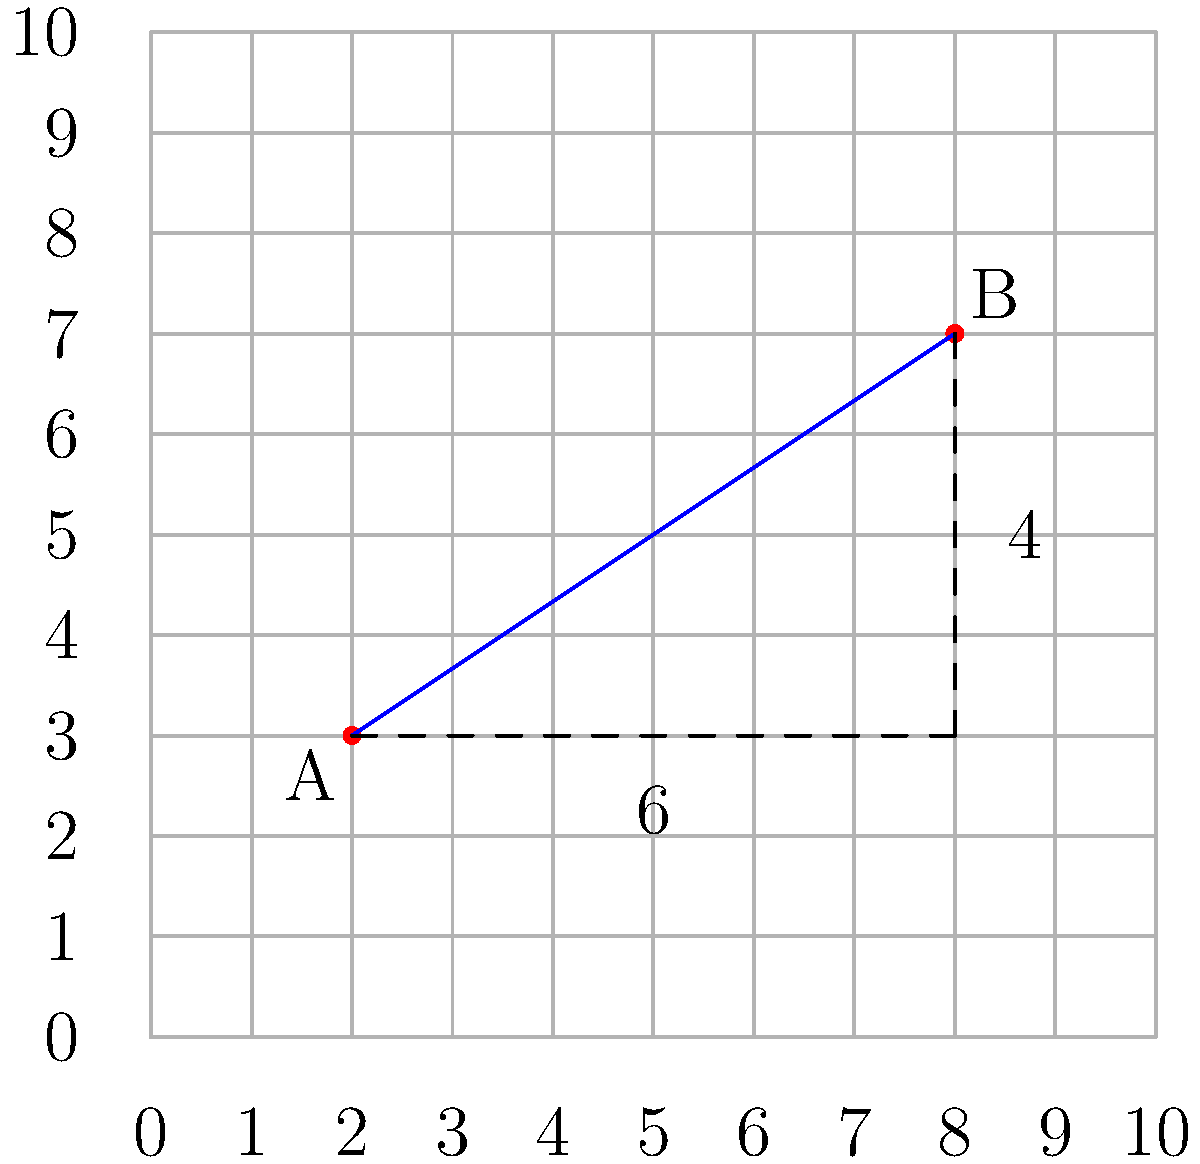As you chart a new territory, you plot two significant landmarks on your map: point A (2, 3) and point B (8, 7). Using the Pythagorean theorem, calculate the direct distance between these two points. Round your answer to two decimal places. To calculate the distance between two points using the Pythagorean theorem, we follow these steps:

1. Identify the coordinates:
   Point A: (2, 3)
   Point B: (8, 7)

2. Calculate the difference in x-coordinates:
   $\Delta x = 8 - 2 = 6$

3. Calculate the difference in y-coordinates:
   $\Delta y = 7 - 3 = 4$

4. Apply the Pythagorean theorem:
   $\text{distance} = \sqrt{(\Delta x)^2 + (\Delta y)^2}$

5. Substitute the values:
   $\text{distance} = \sqrt{6^2 + 4^2}$

6. Simplify:
   $\text{distance} = \sqrt{36 + 16} = \sqrt{52}$

7. Calculate the square root:
   $\text{distance} \approx 7.2111$

8. Round to two decimal places:
   $\text{distance} \approx 7.21$

Therefore, the direct distance between the two landmarks is approximately 7.21 units on your map.
Answer: 7.21 units 